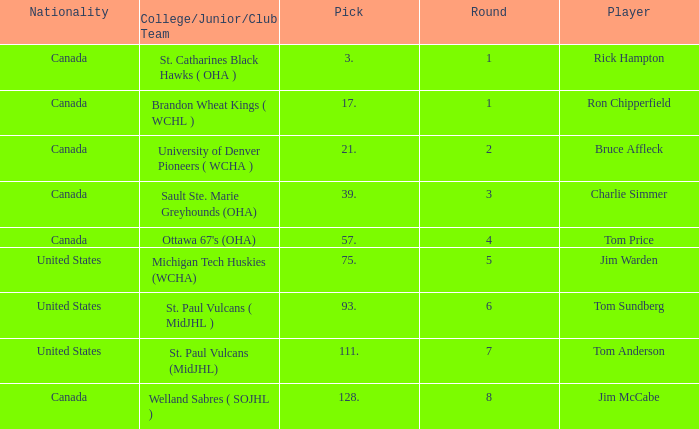Can you tell me the College/Junior/Club Team that has the Round of 4? Ottawa 67's (OHA). 